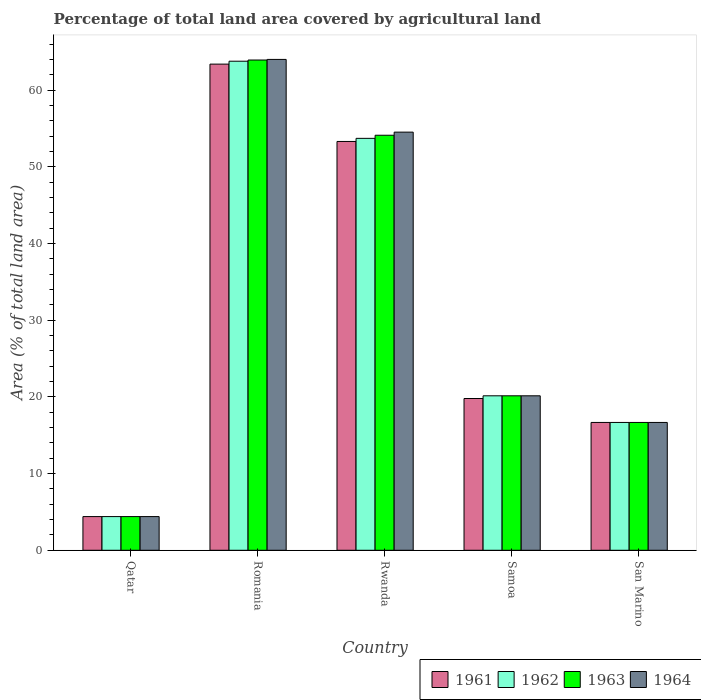How many different coloured bars are there?
Offer a very short reply. 4. How many groups of bars are there?
Your response must be concise. 5. Are the number of bars on each tick of the X-axis equal?
Offer a terse response. Yes. How many bars are there on the 1st tick from the left?
Offer a very short reply. 4. How many bars are there on the 2nd tick from the right?
Provide a succinct answer. 4. What is the label of the 2nd group of bars from the left?
Offer a terse response. Romania. What is the percentage of agricultural land in 1963 in Samoa?
Make the answer very short. 20.14. Across all countries, what is the maximum percentage of agricultural land in 1963?
Your answer should be compact. 63.92. Across all countries, what is the minimum percentage of agricultural land in 1962?
Offer a terse response. 4.39. In which country was the percentage of agricultural land in 1961 maximum?
Keep it short and to the point. Romania. In which country was the percentage of agricultural land in 1964 minimum?
Keep it short and to the point. Qatar. What is the total percentage of agricultural land in 1961 in the graph?
Offer a terse response. 157.54. What is the difference between the percentage of agricultural land in 1964 in Rwanda and that in Samoa?
Offer a terse response. 34.38. What is the difference between the percentage of agricultural land in 1961 in Rwanda and the percentage of agricultural land in 1964 in Samoa?
Offer a very short reply. 33.16. What is the average percentage of agricultural land in 1963 per country?
Keep it short and to the point. 31.85. What is the difference between the percentage of agricultural land of/in 1963 and percentage of agricultural land of/in 1962 in Rwanda?
Provide a succinct answer. 0.41. What is the ratio of the percentage of agricultural land in 1963 in Romania to that in Rwanda?
Make the answer very short. 1.18. What is the difference between the highest and the second highest percentage of agricultural land in 1962?
Provide a succinct answer. -33.57. What is the difference between the highest and the lowest percentage of agricultural land in 1962?
Your answer should be very brief. 59.37. Is it the case that in every country, the sum of the percentage of agricultural land in 1961 and percentage of agricultural land in 1963 is greater than the sum of percentage of agricultural land in 1964 and percentage of agricultural land in 1962?
Give a very brief answer. No. What does the 4th bar from the left in Samoa represents?
Ensure brevity in your answer.  1964. What does the 3rd bar from the right in San Marino represents?
Keep it short and to the point. 1962. Are the values on the major ticks of Y-axis written in scientific E-notation?
Your response must be concise. No. How many legend labels are there?
Make the answer very short. 4. What is the title of the graph?
Your response must be concise. Percentage of total land area covered by agricultural land. Does "2015" appear as one of the legend labels in the graph?
Offer a terse response. No. What is the label or title of the Y-axis?
Your response must be concise. Area (% of total land area). What is the Area (% of total land area) in 1961 in Qatar?
Provide a short and direct response. 4.39. What is the Area (% of total land area) in 1962 in Qatar?
Provide a succinct answer. 4.39. What is the Area (% of total land area) of 1963 in Qatar?
Your answer should be compact. 4.39. What is the Area (% of total land area) of 1964 in Qatar?
Provide a short and direct response. 4.39. What is the Area (% of total land area) of 1961 in Romania?
Your response must be concise. 63.39. What is the Area (% of total land area) in 1962 in Romania?
Your response must be concise. 63.77. What is the Area (% of total land area) of 1963 in Romania?
Your response must be concise. 63.92. What is the Area (% of total land area) in 1964 in Romania?
Your answer should be compact. 64. What is the Area (% of total land area) of 1961 in Rwanda?
Give a very brief answer. 53.3. What is the Area (% of total land area) of 1962 in Rwanda?
Your response must be concise. 53.71. What is the Area (% of total land area) of 1963 in Rwanda?
Your answer should be compact. 54.11. What is the Area (% of total land area) in 1964 in Rwanda?
Provide a short and direct response. 54.52. What is the Area (% of total land area) of 1961 in Samoa?
Offer a terse response. 19.79. What is the Area (% of total land area) of 1962 in Samoa?
Keep it short and to the point. 20.14. What is the Area (% of total land area) in 1963 in Samoa?
Ensure brevity in your answer.  20.14. What is the Area (% of total land area) in 1964 in Samoa?
Your answer should be very brief. 20.14. What is the Area (% of total land area) of 1961 in San Marino?
Keep it short and to the point. 16.67. What is the Area (% of total land area) in 1962 in San Marino?
Give a very brief answer. 16.67. What is the Area (% of total land area) of 1963 in San Marino?
Make the answer very short. 16.67. What is the Area (% of total land area) in 1964 in San Marino?
Your response must be concise. 16.67. Across all countries, what is the maximum Area (% of total land area) in 1961?
Offer a terse response. 63.39. Across all countries, what is the maximum Area (% of total land area) in 1962?
Offer a very short reply. 63.77. Across all countries, what is the maximum Area (% of total land area) in 1963?
Provide a short and direct response. 63.92. Across all countries, what is the maximum Area (% of total land area) of 1964?
Provide a succinct answer. 64. Across all countries, what is the minimum Area (% of total land area) in 1961?
Your answer should be compact. 4.39. Across all countries, what is the minimum Area (% of total land area) in 1962?
Your answer should be compact. 4.39. Across all countries, what is the minimum Area (% of total land area) of 1963?
Your answer should be compact. 4.39. Across all countries, what is the minimum Area (% of total land area) in 1964?
Make the answer very short. 4.39. What is the total Area (% of total land area) of 1961 in the graph?
Offer a very short reply. 157.54. What is the total Area (% of total land area) in 1962 in the graph?
Provide a short and direct response. 158.68. What is the total Area (% of total land area) of 1963 in the graph?
Provide a short and direct response. 159.24. What is the total Area (% of total land area) in 1964 in the graph?
Keep it short and to the point. 159.72. What is the difference between the Area (% of total land area) of 1961 in Qatar and that in Romania?
Your answer should be very brief. -59. What is the difference between the Area (% of total land area) of 1962 in Qatar and that in Romania?
Provide a succinct answer. -59.37. What is the difference between the Area (% of total land area) in 1963 in Qatar and that in Romania?
Provide a succinct answer. -59.53. What is the difference between the Area (% of total land area) in 1964 in Qatar and that in Romania?
Give a very brief answer. -59.61. What is the difference between the Area (% of total land area) of 1961 in Qatar and that in Rwanda?
Keep it short and to the point. -48.91. What is the difference between the Area (% of total land area) in 1962 in Qatar and that in Rwanda?
Ensure brevity in your answer.  -49.32. What is the difference between the Area (% of total land area) of 1963 in Qatar and that in Rwanda?
Your answer should be compact. -49.72. What is the difference between the Area (% of total land area) in 1964 in Qatar and that in Rwanda?
Your answer should be very brief. -50.13. What is the difference between the Area (% of total land area) of 1961 in Qatar and that in Samoa?
Your response must be concise. -15.4. What is the difference between the Area (% of total land area) in 1962 in Qatar and that in Samoa?
Make the answer very short. -15.75. What is the difference between the Area (% of total land area) of 1963 in Qatar and that in Samoa?
Offer a terse response. -15.75. What is the difference between the Area (% of total land area) in 1964 in Qatar and that in Samoa?
Provide a short and direct response. -15.75. What is the difference between the Area (% of total land area) in 1961 in Qatar and that in San Marino?
Make the answer very short. -12.27. What is the difference between the Area (% of total land area) of 1962 in Qatar and that in San Marino?
Your answer should be very brief. -12.27. What is the difference between the Area (% of total land area) in 1963 in Qatar and that in San Marino?
Your answer should be compact. -12.27. What is the difference between the Area (% of total land area) in 1964 in Qatar and that in San Marino?
Offer a terse response. -12.27. What is the difference between the Area (% of total land area) of 1961 in Romania and that in Rwanda?
Ensure brevity in your answer.  10.09. What is the difference between the Area (% of total land area) of 1962 in Romania and that in Rwanda?
Make the answer very short. 10.06. What is the difference between the Area (% of total land area) in 1963 in Romania and that in Rwanda?
Your response must be concise. 9.81. What is the difference between the Area (% of total land area) in 1964 in Romania and that in Rwanda?
Offer a very short reply. 9.48. What is the difference between the Area (% of total land area) of 1961 in Romania and that in Samoa?
Your response must be concise. 43.6. What is the difference between the Area (% of total land area) of 1962 in Romania and that in Samoa?
Your answer should be compact. 43.63. What is the difference between the Area (% of total land area) of 1963 in Romania and that in Samoa?
Give a very brief answer. 43.78. What is the difference between the Area (% of total land area) in 1964 in Romania and that in Samoa?
Offer a terse response. 43.86. What is the difference between the Area (% of total land area) in 1961 in Romania and that in San Marino?
Offer a terse response. 46.72. What is the difference between the Area (% of total land area) in 1962 in Romania and that in San Marino?
Offer a very short reply. 47.1. What is the difference between the Area (% of total land area) of 1963 in Romania and that in San Marino?
Make the answer very short. 47.26. What is the difference between the Area (% of total land area) of 1964 in Romania and that in San Marino?
Offer a terse response. 47.33. What is the difference between the Area (% of total land area) of 1961 in Rwanda and that in Samoa?
Ensure brevity in your answer.  33.52. What is the difference between the Area (% of total land area) of 1962 in Rwanda and that in Samoa?
Your response must be concise. 33.57. What is the difference between the Area (% of total land area) in 1963 in Rwanda and that in Samoa?
Provide a succinct answer. 33.97. What is the difference between the Area (% of total land area) in 1964 in Rwanda and that in Samoa?
Offer a very short reply. 34.38. What is the difference between the Area (% of total land area) of 1961 in Rwanda and that in San Marino?
Keep it short and to the point. 36.64. What is the difference between the Area (% of total land area) in 1962 in Rwanda and that in San Marino?
Provide a succinct answer. 37.04. What is the difference between the Area (% of total land area) in 1963 in Rwanda and that in San Marino?
Offer a terse response. 37.45. What is the difference between the Area (% of total land area) of 1964 in Rwanda and that in San Marino?
Provide a succinct answer. 37.85. What is the difference between the Area (% of total land area) of 1961 in Samoa and that in San Marino?
Give a very brief answer. 3.12. What is the difference between the Area (% of total land area) of 1962 in Samoa and that in San Marino?
Your answer should be compact. 3.47. What is the difference between the Area (% of total land area) in 1963 in Samoa and that in San Marino?
Offer a terse response. 3.47. What is the difference between the Area (% of total land area) in 1964 in Samoa and that in San Marino?
Your answer should be very brief. 3.47. What is the difference between the Area (% of total land area) of 1961 in Qatar and the Area (% of total land area) of 1962 in Romania?
Offer a terse response. -59.37. What is the difference between the Area (% of total land area) of 1961 in Qatar and the Area (% of total land area) of 1963 in Romania?
Offer a terse response. -59.53. What is the difference between the Area (% of total land area) of 1961 in Qatar and the Area (% of total land area) of 1964 in Romania?
Provide a succinct answer. -59.61. What is the difference between the Area (% of total land area) of 1962 in Qatar and the Area (% of total land area) of 1963 in Romania?
Ensure brevity in your answer.  -59.53. What is the difference between the Area (% of total land area) in 1962 in Qatar and the Area (% of total land area) in 1964 in Romania?
Make the answer very short. -59.61. What is the difference between the Area (% of total land area) of 1963 in Qatar and the Area (% of total land area) of 1964 in Romania?
Give a very brief answer. -59.61. What is the difference between the Area (% of total land area) in 1961 in Qatar and the Area (% of total land area) in 1962 in Rwanda?
Offer a terse response. -49.32. What is the difference between the Area (% of total land area) in 1961 in Qatar and the Area (% of total land area) in 1963 in Rwanda?
Ensure brevity in your answer.  -49.72. What is the difference between the Area (% of total land area) of 1961 in Qatar and the Area (% of total land area) of 1964 in Rwanda?
Make the answer very short. -50.13. What is the difference between the Area (% of total land area) in 1962 in Qatar and the Area (% of total land area) in 1963 in Rwanda?
Keep it short and to the point. -49.72. What is the difference between the Area (% of total land area) in 1962 in Qatar and the Area (% of total land area) in 1964 in Rwanda?
Make the answer very short. -50.13. What is the difference between the Area (% of total land area) in 1963 in Qatar and the Area (% of total land area) in 1964 in Rwanda?
Make the answer very short. -50.13. What is the difference between the Area (% of total land area) in 1961 in Qatar and the Area (% of total land area) in 1962 in Samoa?
Give a very brief answer. -15.75. What is the difference between the Area (% of total land area) in 1961 in Qatar and the Area (% of total land area) in 1963 in Samoa?
Your response must be concise. -15.75. What is the difference between the Area (% of total land area) of 1961 in Qatar and the Area (% of total land area) of 1964 in Samoa?
Make the answer very short. -15.75. What is the difference between the Area (% of total land area) in 1962 in Qatar and the Area (% of total land area) in 1963 in Samoa?
Offer a very short reply. -15.75. What is the difference between the Area (% of total land area) in 1962 in Qatar and the Area (% of total land area) in 1964 in Samoa?
Your answer should be very brief. -15.75. What is the difference between the Area (% of total land area) of 1963 in Qatar and the Area (% of total land area) of 1964 in Samoa?
Offer a very short reply. -15.75. What is the difference between the Area (% of total land area) in 1961 in Qatar and the Area (% of total land area) in 1962 in San Marino?
Make the answer very short. -12.27. What is the difference between the Area (% of total land area) of 1961 in Qatar and the Area (% of total land area) of 1963 in San Marino?
Ensure brevity in your answer.  -12.27. What is the difference between the Area (% of total land area) in 1961 in Qatar and the Area (% of total land area) in 1964 in San Marino?
Offer a very short reply. -12.27. What is the difference between the Area (% of total land area) in 1962 in Qatar and the Area (% of total land area) in 1963 in San Marino?
Keep it short and to the point. -12.27. What is the difference between the Area (% of total land area) of 1962 in Qatar and the Area (% of total land area) of 1964 in San Marino?
Keep it short and to the point. -12.27. What is the difference between the Area (% of total land area) in 1963 in Qatar and the Area (% of total land area) in 1964 in San Marino?
Your answer should be compact. -12.27. What is the difference between the Area (% of total land area) in 1961 in Romania and the Area (% of total land area) in 1962 in Rwanda?
Provide a short and direct response. 9.68. What is the difference between the Area (% of total land area) in 1961 in Romania and the Area (% of total land area) in 1963 in Rwanda?
Your answer should be compact. 9.27. What is the difference between the Area (% of total land area) in 1961 in Romania and the Area (% of total land area) in 1964 in Rwanda?
Offer a very short reply. 8.87. What is the difference between the Area (% of total land area) in 1962 in Romania and the Area (% of total land area) in 1963 in Rwanda?
Keep it short and to the point. 9.65. What is the difference between the Area (% of total land area) in 1962 in Romania and the Area (% of total land area) in 1964 in Rwanda?
Offer a very short reply. 9.25. What is the difference between the Area (% of total land area) in 1963 in Romania and the Area (% of total land area) in 1964 in Rwanda?
Give a very brief answer. 9.4. What is the difference between the Area (% of total land area) in 1961 in Romania and the Area (% of total land area) in 1962 in Samoa?
Your answer should be very brief. 43.25. What is the difference between the Area (% of total land area) of 1961 in Romania and the Area (% of total land area) of 1963 in Samoa?
Your response must be concise. 43.25. What is the difference between the Area (% of total land area) of 1961 in Romania and the Area (% of total land area) of 1964 in Samoa?
Your answer should be very brief. 43.25. What is the difference between the Area (% of total land area) in 1962 in Romania and the Area (% of total land area) in 1963 in Samoa?
Ensure brevity in your answer.  43.63. What is the difference between the Area (% of total land area) of 1962 in Romania and the Area (% of total land area) of 1964 in Samoa?
Keep it short and to the point. 43.63. What is the difference between the Area (% of total land area) of 1963 in Romania and the Area (% of total land area) of 1964 in Samoa?
Your answer should be very brief. 43.78. What is the difference between the Area (% of total land area) in 1961 in Romania and the Area (% of total land area) in 1962 in San Marino?
Give a very brief answer. 46.72. What is the difference between the Area (% of total land area) of 1961 in Romania and the Area (% of total land area) of 1963 in San Marino?
Provide a succinct answer. 46.72. What is the difference between the Area (% of total land area) of 1961 in Romania and the Area (% of total land area) of 1964 in San Marino?
Give a very brief answer. 46.72. What is the difference between the Area (% of total land area) of 1962 in Romania and the Area (% of total land area) of 1963 in San Marino?
Give a very brief answer. 47.1. What is the difference between the Area (% of total land area) in 1962 in Romania and the Area (% of total land area) in 1964 in San Marino?
Offer a very short reply. 47.1. What is the difference between the Area (% of total land area) in 1963 in Romania and the Area (% of total land area) in 1964 in San Marino?
Provide a short and direct response. 47.26. What is the difference between the Area (% of total land area) of 1961 in Rwanda and the Area (% of total land area) of 1962 in Samoa?
Give a very brief answer. 33.16. What is the difference between the Area (% of total land area) in 1961 in Rwanda and the Area (% of total land area) in 1963 in Samoa?
Offer a terse response. 33.16. What is the difference between the Area (% of total land area) of 1961 in Rwanda and the Area (% of total land area) of 1964 in Samoa?
Your answer should be compact. 33.16. What is the difference between the Area (% of total land area) of 1962 in Rwanda and the Area (% of total land area) of 1963 in Samoa?
Ensure brevity in your answer.  33.57. What is the difference between the Area (% of total land area) in 1962 in Rwanda and the Area (% of total land area) in 1964 in Samoa?
Provide a short and direct response. 33.57. What is the difference between the Area (% of total land area) of 1963 in Rwanda and the Area (% of total land area) of 1964 in Samoa?
Give a very brief answer. 33.97. What is the difference between the Area (% of total land area) of 1961 in Rwanda and the Area (% of total land area) of 1962 in San Marino?
Give a very brief answer. 36.64. What is the difference between the Area (% of total land area) of 1961 in Rwanda and the Area (% of total land area) of 1963 in San Marino?
Offer a very short reply. 36.64. What is the difference between the Area (% of total land area) in 1961 in Rwanda and the Area (% of total land area) in 1964 in San Marino?
Keep it short and to the point. 36.64. What is the difference between the Area (% of total land area) in 1962 in Rwanda and the Area (% of total land area) in 1963 in San Marino?
Offer a very short reply. 37.04. What is the difference between the Area (% of total land area) in 1962 in Rwanda and the Area (% of total land area) in 1964 in San Marino?
Your response must be concise. 37.04. What is the difference between the Area (% of total land area) of 1963 in Rwanda and the Area (% of total land area) of 1964 in San Marino?
Make the answer very short. 37.45. What is the difference between the Area (% of total land area) in 1961 in Samoa and the Area (% of total land area) in 1962 in San Marino?
Your answer should be compact. 3.12. What is the difference between the Area (% of total land area) of 1961 in Samoa and the Area (% of total land area) of 1963 in San Marino?
Keep it short and to the point. 3.12. What is the difference between the Area (% of total land area) of 1961 in Samoa and the Area (% of total land area) of 1964 in San Marino?
Give a very brief answer. 3.12. What is the difference between the Area (% of total land area) of 1962 in Samoa and the Area (% of total land area) of 1963 in San Marino?
Give a very brief answer. 3.47. What is the difference between the Area (% of total land area) in 1962 in Samoa and the Area (% of total land area) in 1964 in San Marino?
Provide a short and direct response. 3.47. What is the difference between the Area (% of total land area) in 1963 in Samoa and the Area (% of total land area) in 1964 in San Marino?
Provide a short and direct response. 3.47. What is the average Area (% of total land area) of 1961 per country?
Offer a very short reply. 31.51. What is the average Area (% of total land area) of 1962 per country?
Provide a short and direct response. 31.74. What is the average Area (% of total land area) of 1963 per country?
Offer a very short reply. 31.85. What is the average Area (% of total land area) in 1964 per country?
Your answer should be compact. 31.94. What is the difference between the Area (% of total land area) in 1961 and Area (% of total land area) in 1962 in Qatar?
Provide a short and direct response. 0. What is the difference between the Area (% of total land area) of 1962 and Area (% of total land area) of 1963 in Qatar?
Provide a short and direct response. 0. What is the difference between the Area (% of total land area) in 1963 and Area (% of total land area) in 1964 in Qatar?
Make the answer very short. 0. What is the difference between the Area (% of total land area) in 1961 and Area (% of total land area) in 1962 in Romania?
Keep it short and to the point. -0.38. What is the difference between the Area (% of total land area) of 1961 and Area (% of total land area) of 1963 in Romania?
Provide a succinct answer. -0.53. What is the difference between the Area (% of total land area) in 1961 and Area (% of total land area) in 1964 in Romania?
Provide a short and direct response. -0.61. What is the difference between the Area (% of total land area) in 1962 and Area (% of total land area) in 1963 in Romania?
Give a very brief answer. -0.16. What is the difference between the Area (% of total land area) in 1962 and Area (% of total land area) in 1964 in Romania?
Offer a very short reply. -0.23. What is the difference between the Area (% of total land area) of 1963 and Area (% of total land area) of 1964 in Romania?
Provide a short and direct response. -0.08. What is the difference between the Area (% of total land area) in 1961 and Area (% of total land area) in 1962 in Rwanda?
Make the answer very short. -0.41. What is the difference between the Area (% of total land area) in 1961 and Area (% of total land area) in 1963 in Rwanda?
Give a very brief answer. -0.81. What is the difference between the Area (% of total land area) of 1961 and Area (% of total land area) of 1964 in Rwanda?
Provide a succinct answer. -1.22. What is the difference between the Area (% of total land area) in 1962 and Area (% of total land area) in 1963 in Rwanda?
Your answer should be very brief. -0.41. What is the difference between the Area (% of total land area) of 1962 and Area (% of total land area) of 1964 in Rwanda?
Keep it short and to the point. -0.81. What is the difference between the Area (% of total land area) of 1963 and Area (% of total land area) of 1964 in Rwanda?
Provide a succinct answer. -0.41. What is the difference between the Area (% of total land area) in 1961 and Area (% of total land area) in 1962 in Samoa?
Make the answer very short. -0.35. What is the difference between the Area (% of total land area) of 1961 and Area (% of total land area) of 1963 in Samoa?
Offer a terse response. -0.35. What is the difference between the Area (% of total land area) of 1961 and Area (% of total land area) of 1964 in Samoa?
Offer a terse response. -0.35. What is the difference between the Area (% of total land area) in 1962 and Area (% of total land area) in 1963 in Samoa?
Your answer should be very brief. 0. What is the difference between the Area (% of total land area) of 1961 and Area (% of total land area) of 1962 in San Marino?
Give a very brief answer. 0. What is the difference between the Area (% of total land area) of 1961 and Area (% of total land area) of 1964 in San Marino?
Your response must be concise. 0. What is the difference between the Area (% of total land area) of 1963 and Area (% of total land area) of 1964 in San Marino?
Offer a terse response. 0. What is the ratio of the Area (% of total land area) of 1961 in Qatar to that in Romania?
Your answer should be very brief. 0.07. What is the ratio of the Area (% of total land area) in 1962 in Qatar to that in Romania?
Provide a succinct answer. 0.07. What is the ratio of the Area (% of total land area) in 1963 in Qatar to that in Romania?
Offer a very short reply. 0.07. What is the ratio of the Area (% of total land area) in 1964 in Qatar to that in Romania?
Provide a short and direct response. 0.07. What is the ratio of the Area (% of total land area) in 1961 in Qatar to that in Rwanda?
Your answer should be compact. 0.08. What is the ratio of the Area (% of total land area) in 1962 in Qatar to that in Rwanda?
Your answer should be very brief. 0.08. What is the ratio of the Area (% of total land area) of 1963 in Qatar to that in Rwanda?
Ensure brevity in your answer.  0.08. What is the ratio of the Area (% of total land area) in 1964 in Qatar to that in Rwanda?
Provide a short and direct response. 0.08. What is the ratio of the Area (% of total land area) of 1961 in Qatar to that in Samoa?
Offer a terse response. 0.22. What is the ratio of the Area (% of total land area) in 1962 in Qatar to that in Samoa?
Keep it short and to the point. 0.22. What is the ratio of the Area (% of total land area) of 1963 in Qatar to that in Samoa?
Ensure brevity in your answer.  0.22. What is the ratio of the Area (% of total land area) in 1964 in Qatar to that in Samoa?
Your response must be concise. 0.22. What is the ratio of the Area (% of total land area) in 1961 in Qatar to that in San Marino?
Your answer should be very brief. 0.26. What is the ratio of the Area (% of total land area) in 1962 in Qatar to that in San Marino?
Keep it short and to the point. 0.26. What is the ratio of the Area (% of total land area) in 1963 in Qatar to that in San Marino?
Offer a very short reply. 0.26. What is the ratio of the Area (% of total land area) of 1964 in Qatar to that in San Marino?
Your response must be concise. 0.26. What is the ratio of the Area (% of total land area) in 1961 in Romania to that in Rwanda?
Provide a short and direct response. 1.19. What is the ratio of the Area (% of total land area) of 1962 in Romania to that in Rwanda?
Ensure brevity in your answer.  1.19. What is the ratio of the Area (% of total land area) of 1963 in Romania to that in Rwanda?
Ensure brevity in your answer.  1.18. What is the ratio of the Area (% of total land area) of 1964 in Romania to that in Rwanda?
Offer a very short reply. 1.17. What is the ratio of the Area (% of total land area) of 1961 in Romania to that in Samoa?
Offer a terse response. 3.2. What is the ratio of the Area (% of total land area) of 1962 in Romania to that in Samoa?
Your answer should be very brief. 3.17. What is the ratio of the Area (% of total land area) in 1963 in Romania to that in Samoa?
Offer a terse response. 3.17. What is the ratio of the Area (% of total land area) of 1964 in Romania to that in Samoa?
Provide a succinct answer. 3.18. What is the ratio of the Area (% of total land area) of 1961 in Romania to that in San Marino?
Provide a succinct answer. 3.8. What is the ratio of the Area (% of total land area) of 1962 in Romania to that in San Marino?
Your response must be concise. 3.83. What is the ratio of the Area (% of total land area) in 1963 in Romania to that in San Marino?
Ensure brevity in your answer.  3.84. What is the ratio of the Area (% of total land area) in 1964 in Romania to that in San Marino?
Offer a terse response. 3.84. What is the ratio of the Area (% of total land area) in 1961 in Rwanda to that in Samoa?
Your response must be concise. 2.69. What is the ratio of the Area (% of total land area) in 1962 in Rwanda to that in Samoa?
Keep it short and to the point. 2.67. What is the ratio of the Area (% of total land area) in 1963 in Rwanda to that in Samoa?
Make the answer very short. 2.69. What is the ratio of the Area (% of total land area) in 1964 in Rwanda to that in Samoa?
Your response must be concise. 2.71. What is the ratio of the Area (% of total land area) in 1961 in Rwanda to that in San Marino?
Your response must be concise. 3.2. What is the ratio of the Area (% of total land area) of 1962 in Rwanda to that in San Marino?
Offer a very short reply. 3.22. What is the ratio of the Area (% of total land area) in 1963 in Rwanda to that in San Marino?
Offer a very short reply. 3.25. What is the ratio of the Area (% of total land area) of 1964 in Rwanda to that in San Marino?
Provide a short and direct response. 3.27. What is the ratio of the Area (% of total land area) in 1961 in Samoa to that in San Marino?
Your answer should be compact. 1.19. What is the ratio of the Area (% of total land area) in 1962 in Samoa to that in San Marino?
Offer a very short reply. 1.21. What is the ratio of the Area (% of total land area) of 1963 in Samoa to that in San Marino?
Make the answer very short. 1.21. What is the ratio of the Area (% of total land area) of 1964 in Samoa to that in San Marino?
Offer a very short reply. 1.21. What is the difference between the highest and the second highest Area (% of total land area) in 1961?
Offer a very short reply. 10.09. What is the difference between the highest and the second highest Area (% of total land area) in 1962?
Your answer should be compact. 10.06. What is the difference between the highest and the second highest Area (% of total land area) of 1963?
Ensure brevity in your answer.  9.81. What is the difference between the highest and the second highest Area (% of total land area) in 1964?
Provide a short and direct response. 9.48. What is the difference between the highest and the lowest Area (% of total land area) in 1961?
Your response must be concise. 59. What is the difference between the highest and the lowest Area (% of total land area) of 1962?
Make the answer very short. 59.37. What is the difference between the highest and the lowest Area (% of total land area) in 1963?
Offer a terse response. 59.53. What is the difference between the highest and the lowest Area (% of total land area) of 1964?
Offer a very short reply. 59.61. 